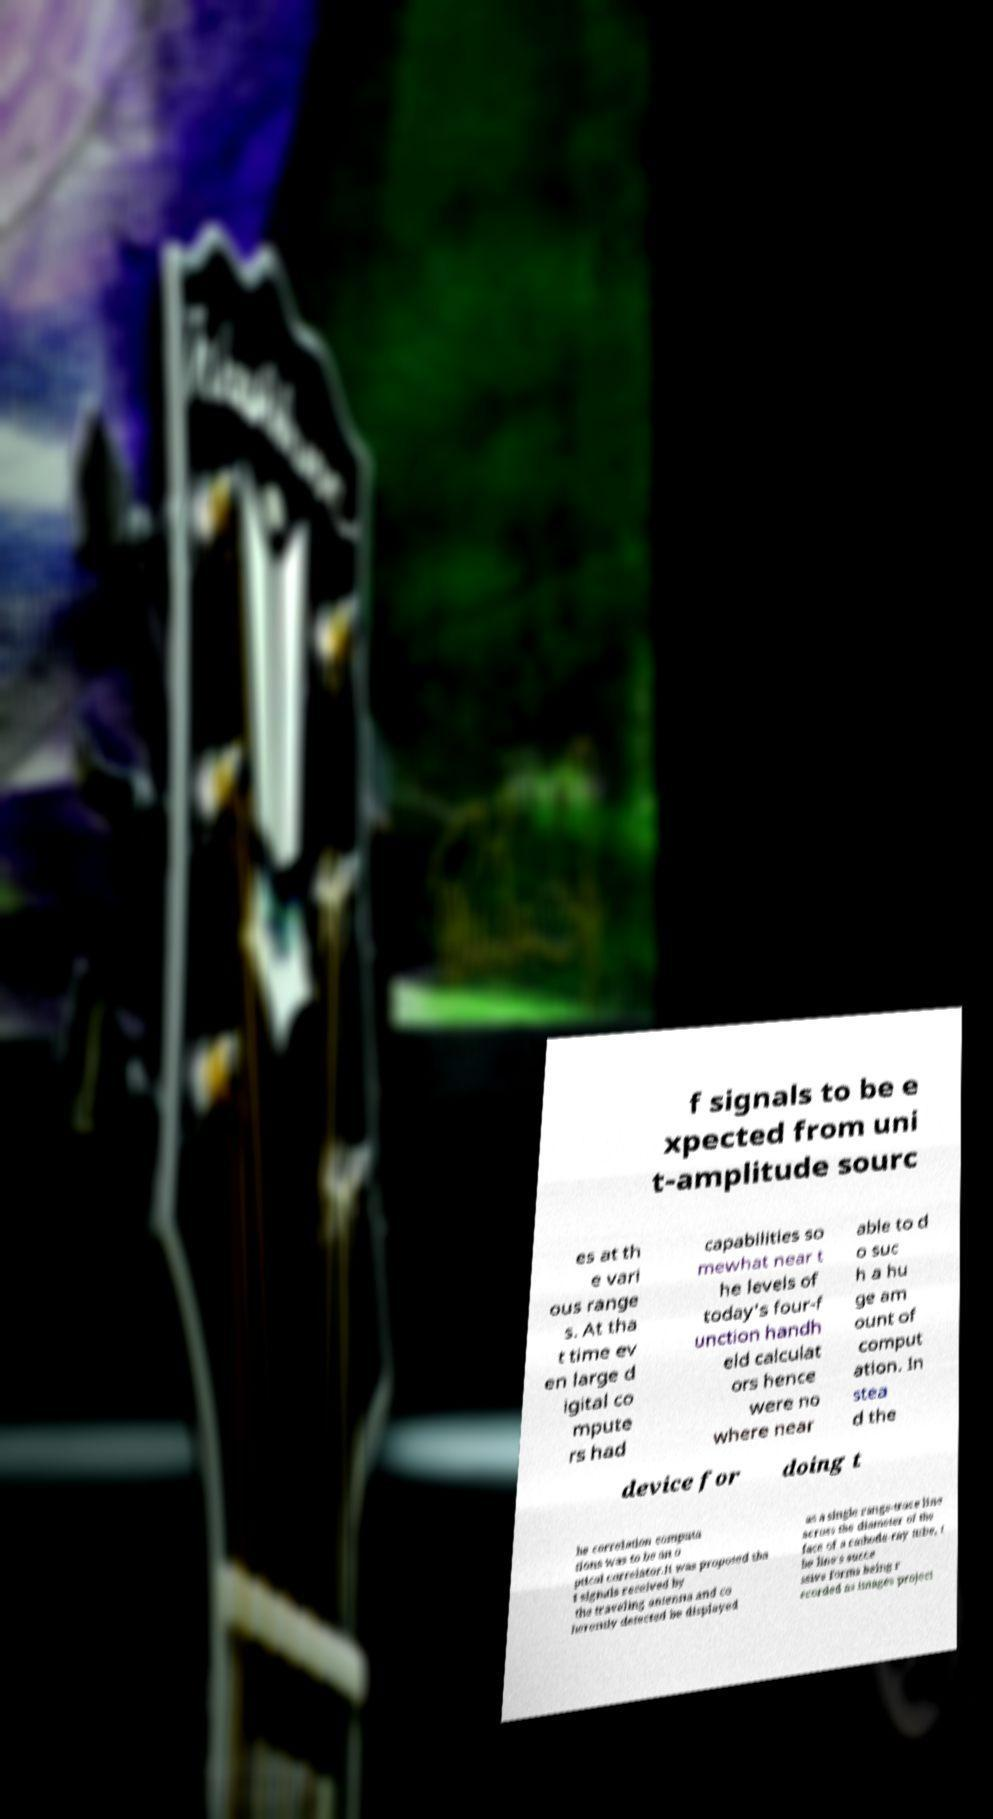Can you read and provide the text displayed in the image?This photo seems to have some interesting text. Can you extract and type it out for me? f signals to be e xpected from uni t-amplitude sourc es at th e vari ous range s. At tha t time ev en large d igital co mpute rs had capabilities so mewhat near t he levels of today's four-f unction handh eld calculat ors hence were no where near able to d o suc h a hu ge am ount of comput ation. In stea d the device for doing t he correlation computa tions was to be an o ptical correlator.It was proposed tha t signals received by the traveling antenna and co herently detected be displayed as a single range-trace line across the diameter of the face of a cathode-ray tube, t he line's succe ssive forms being r ecorded as images project 